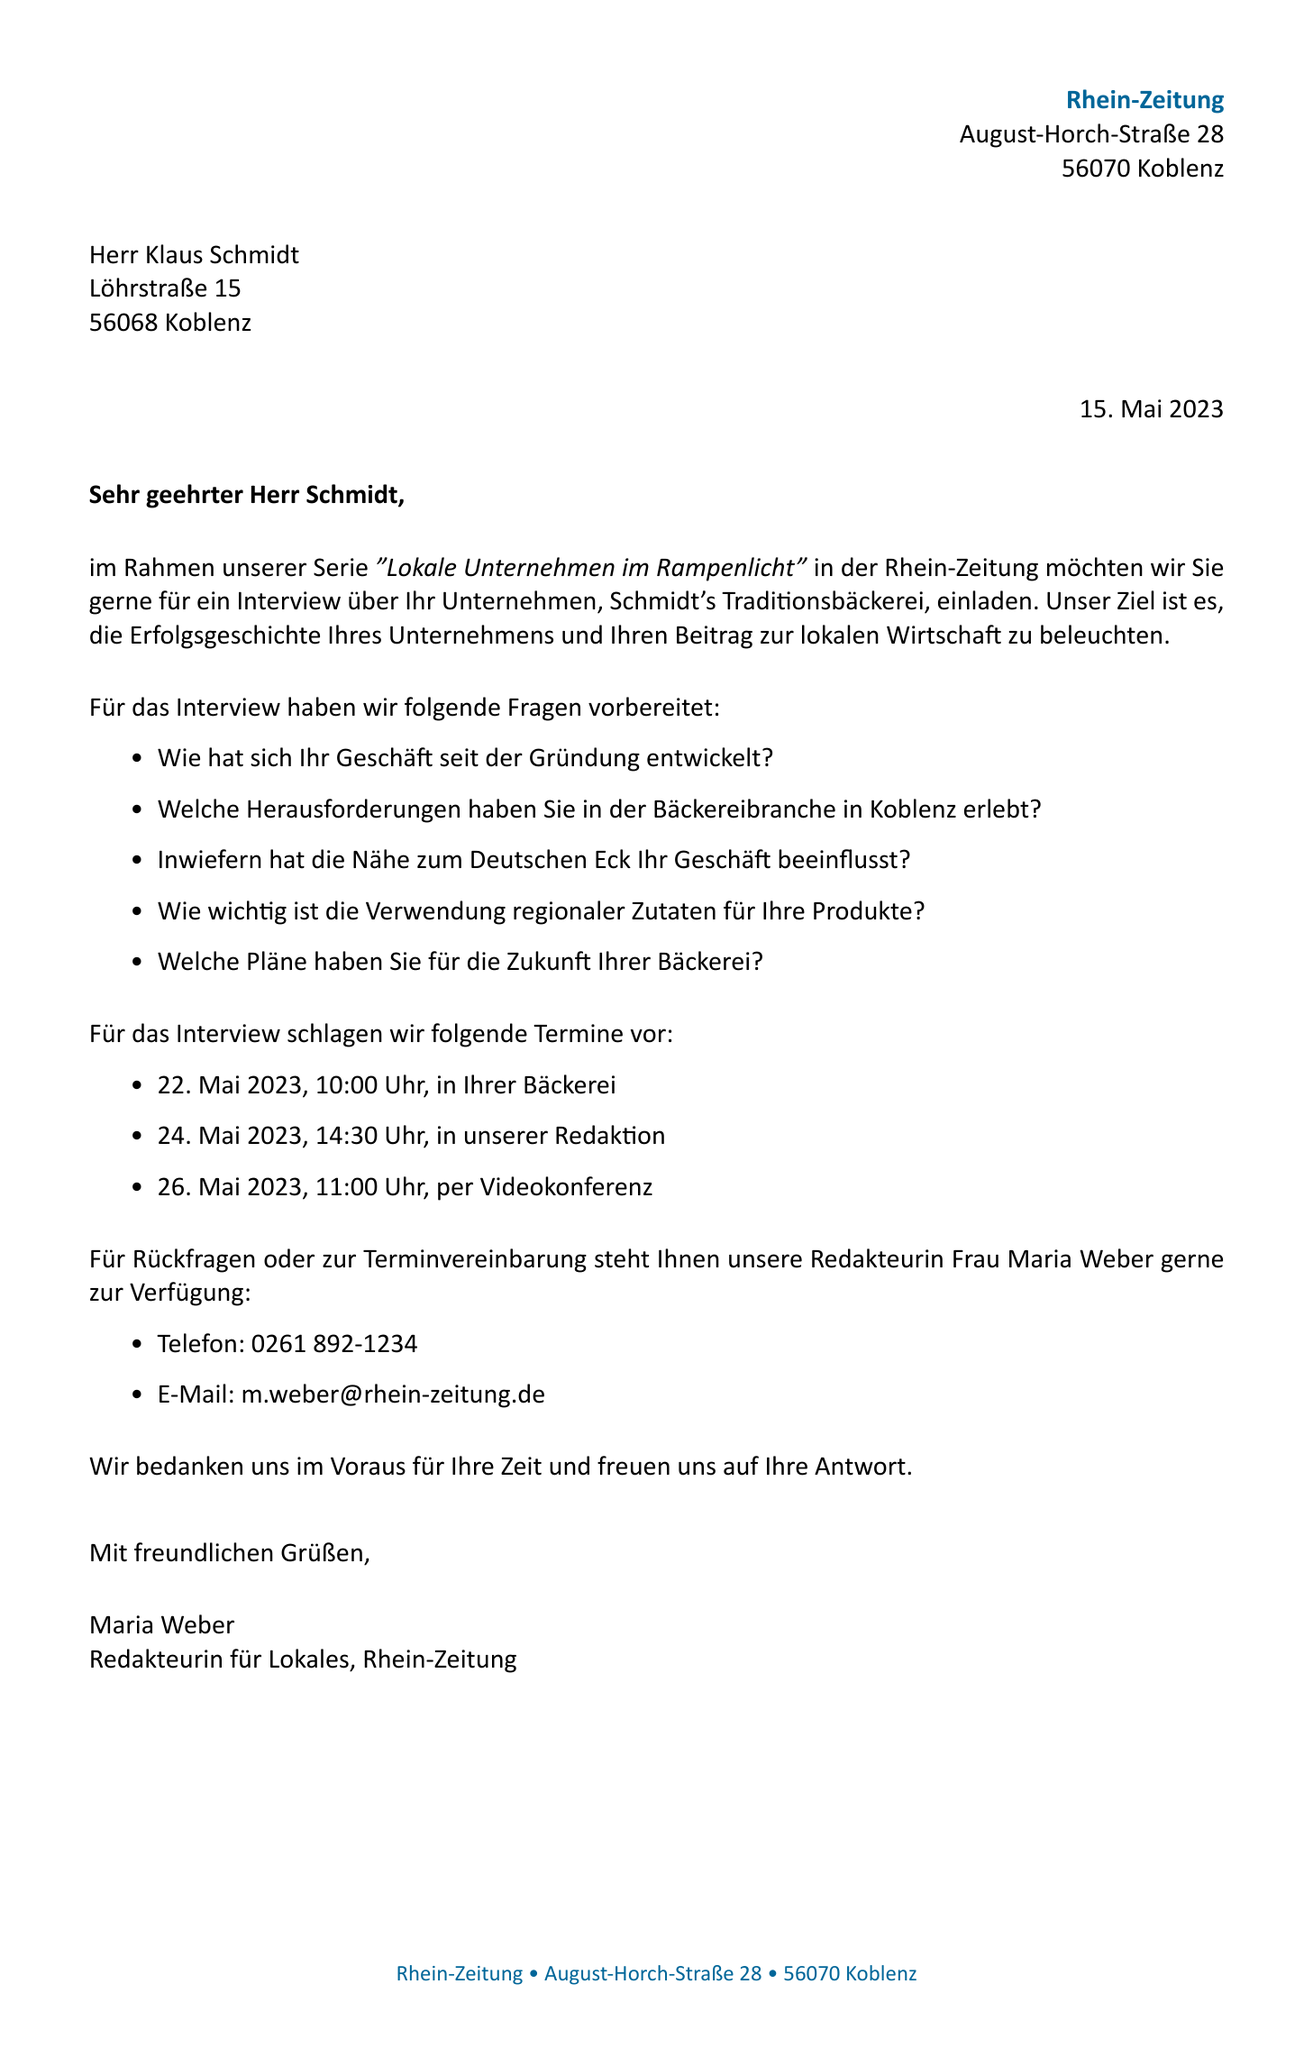What is the date of the letter? The date of the letter, stated in the document, is an important piece of information.
Answer: 15. Mai 2023 Who is the recipient of the letter? The recipient's name is provided in the document header, indicating who the letter is addressed to.
Answer: Herr Klaus Schmidt What is the business name mentioned in the letter? The business name is highlighted in the introduction section of the document, identifying the company for the interview.
Answer: Schmidt's Traditionsbäckerei How many proposed interview dates are listed? The document provides a list of proposed dates for the interview, allowing for scheduling options.
Answer: 3 What is the purpose of the interview? The document explains the intention behind the interview, which helps understand the context of the interaction.
Answer: um die Erfolgsgeschichte Ihres Unternehmens und Ihren Beitrag zur lokalen Wirtschaft zu beleuchten Who is the journalist contacting for the interview? The letter mentions the journalist's name who will handle the communication regarding the interview scheduling.
Answer: Frau Maria Weber What is one of the proposed interview locations? The document lists several locations where the interview can take place, indicating flexibility in scheduling.
Answer: In Ihrer Bäckerei What type of document is this? This specific type of document serves a particular purpose and structure, indicating its classification.
Answer: Letter 